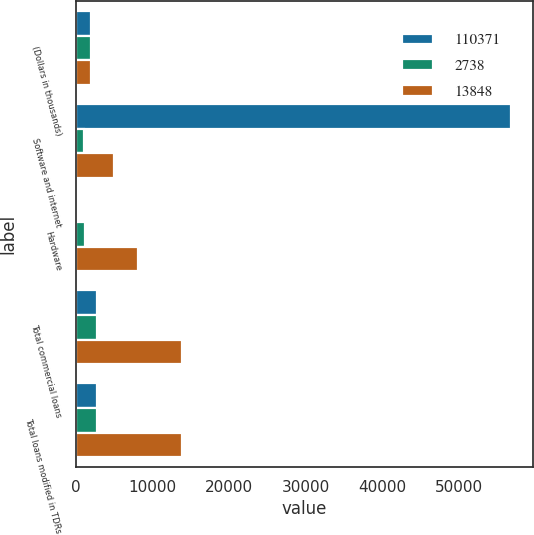Convert chart. <chart><loc_0><loc_0><loc_500><loc_500><stacked_bar_chart><ecel><fcel>(Dollars in thousands)<fcel>Software and internet<fcel>Hardware<fcel>Total commercial loans<fcel>Total loans modified in TDRs<nl><fcel>110371<fcel>2015<fcel>56790<fcel>286<fcel>2738<fcel>2738<nl><fcel>2738<fcel>2014<fcel>1033<fcel>1118<fcel>2738<fcel>2738<nl><fcel>13848<fcel>2013<fcel>4932<fcel>8143<fcel>13842<fcel>13848<nl></chart> 